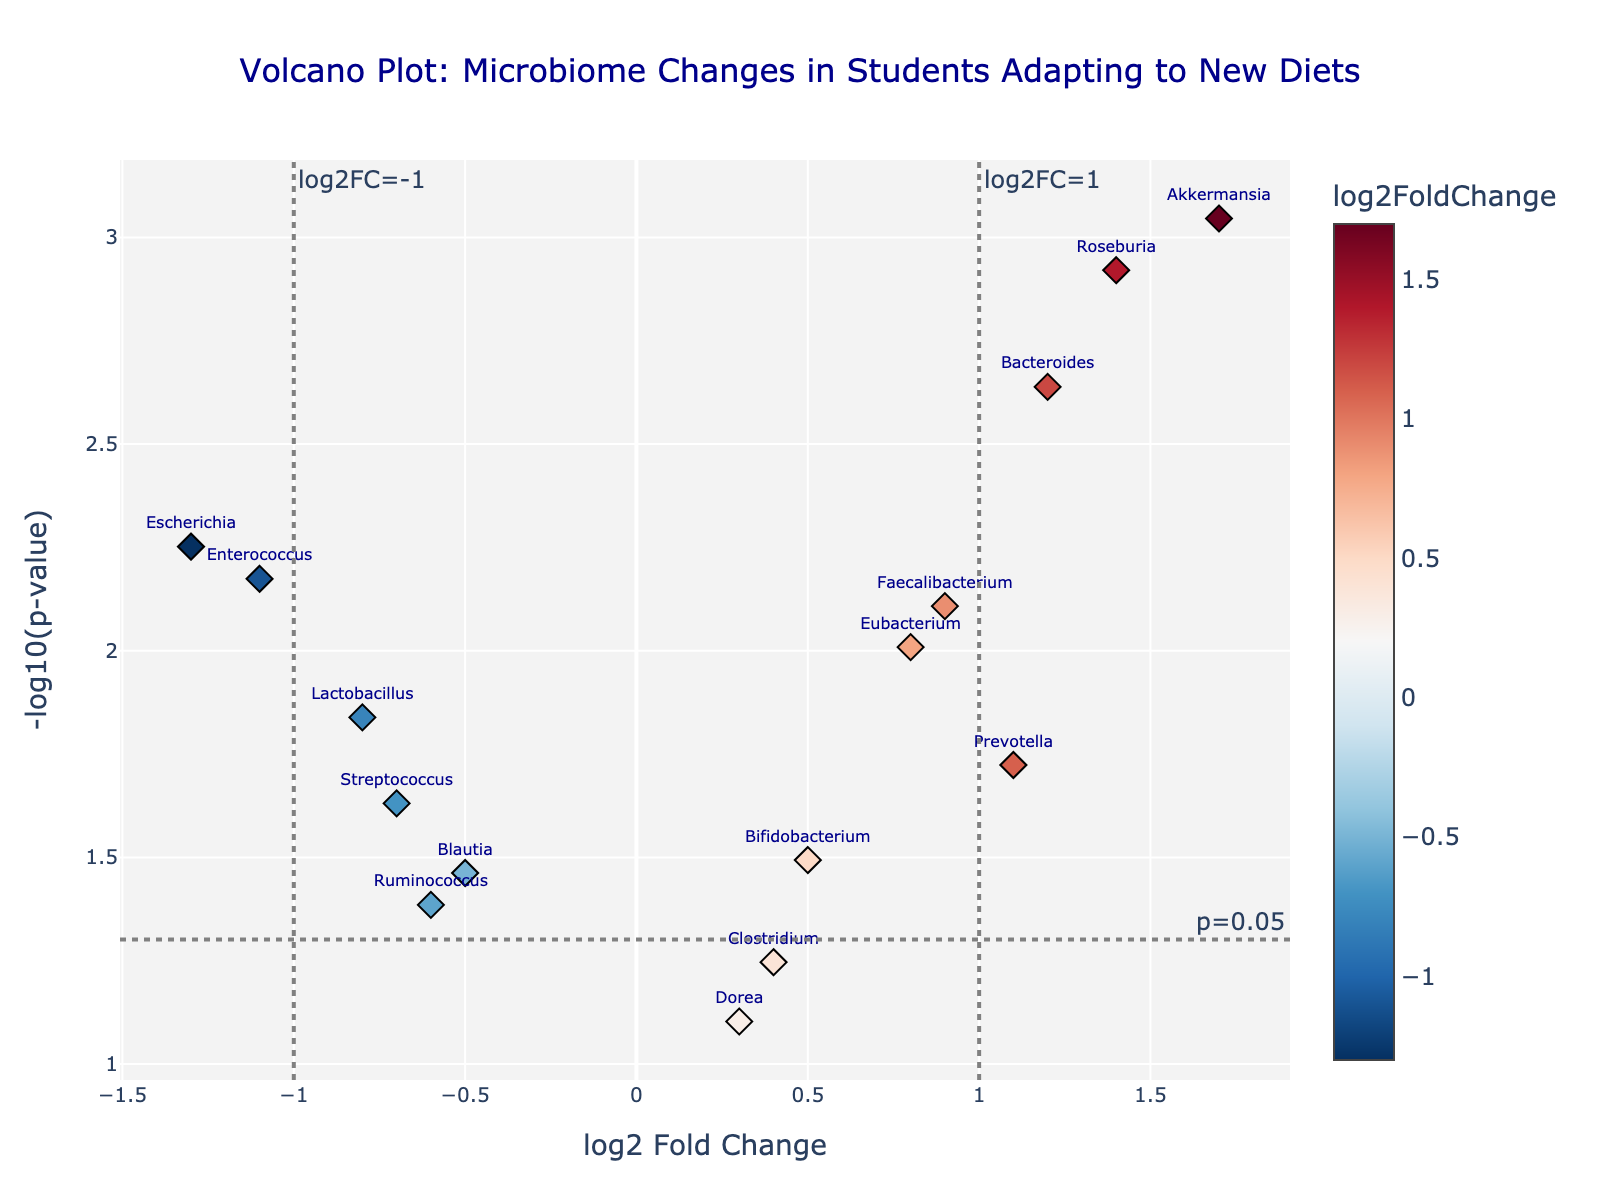What does the title of the plot say? The plot has a title at the top which provides an overview of what the plot represents. The title is clearly mentioned in the figure.
Answer: "Volcano Plot: Microbiome Changes in Students Adapting to New Diets" What are the labels of the X and Y axes? The X and Y axes labels are provided on the figure to indicate what is being measured on each axis. The X axis represents log2 Fold Change, and the Y axis represents -log10(p-value).
Answer: log2 Fold Change, -log10(p-value) How many points are plotted on the Volcano Plot? By counting the number of individual markers on the plot, you can determine the number of data points.
Answer: 15 Which bacterium has the highest log2 Fold Change? To determine this, observe the X-axis for the highest value and note the corresponding bacterium. Akkermansia is at the farthest right on the X-axis with log2 Fold Change of 1.7.
Answer: Akkermansia What does a point's color represent in the plot? The color of each point is based on the log2 Fold Change value and is presented through a color scale.
Answer: log2 Fold Change Which bacterium has the smallest p-value? The lowest p-value corresponds to the highest value on the Y-axis (-log10(p-value)). Look for the highest point on the Y-axis.
Answer: Akkermansia How many bacteria have a log2 Fold Change greater than 1? Identify points on the X-axis that are greater than 1 and count them. There are three such bacteria: Bacteroides, Akkermansia, and Roseburia.
Answer: 3 Which bacterium is closest to the threshold line for a p-value of 0.05? Look at the horizontal line where the Y-axis is -log10(0.05) and find the point closest to it. Clostridium is closest to this threshold line.
Answer: Clostridium How many bacteria have a log2 Fold Change less than -1 and significant p-value (p < 0.05)? Check the points on the left of X=-1 and above the horizontal p-value threshold line. Only Escherichia meets these criteria.
Answer: 1 What is the log2 Fold Change and p-value of the bacterium Roseburia? Look at the plot for Roseburia and find its hover text which shows the log2 Fold Change and p-value.
Answer: log2 Fold Change: 1.4, p-value: 0.0012 